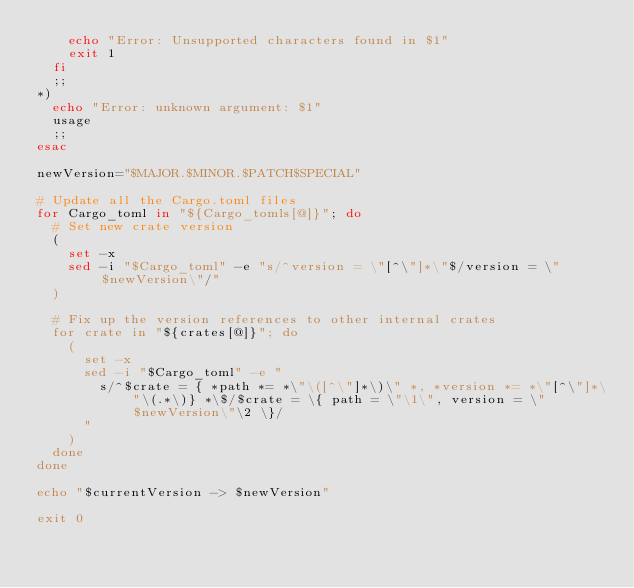<code> <loc_0><loc_0><loc_500><loc_500><_Bash_>    echo "Error: Unsupported characters found in $1"
    exit 1
  fi
  ;;
*)
  echo "Error: unknown argument: $1"
  usage
  ;;
esac

newVersion="$MAJOR.$MINOR.$PATCH$SPECIAL"

# Update all the Cargo.toml files
for Cargo_toml in "${Cargo_tomls[@]}"; do
  # Set new crate version
  (
    set -x
    sed -i "$Cargo_toml" -e "s/^version = \"[^\"]*\"$/version = \"$newVersion\"/"
  )

  # Fix up the version references to other internal crates
  for crate in "${crates[@]}"; do
    (
      set -x
      sed -i "$Cargo_toml" -e "
        s/^$crate = { *path *= *\"\([^\"]*\)\" *, *version *= *\"[^\"]*\"\(.*\)} *\$/$crate = \{ path = \"\1\", version = \"$newVersion\"\2 \}/
      "
    )
  done
done

echo "$currentVersion -> $newVersion"

exit 0
</code> 